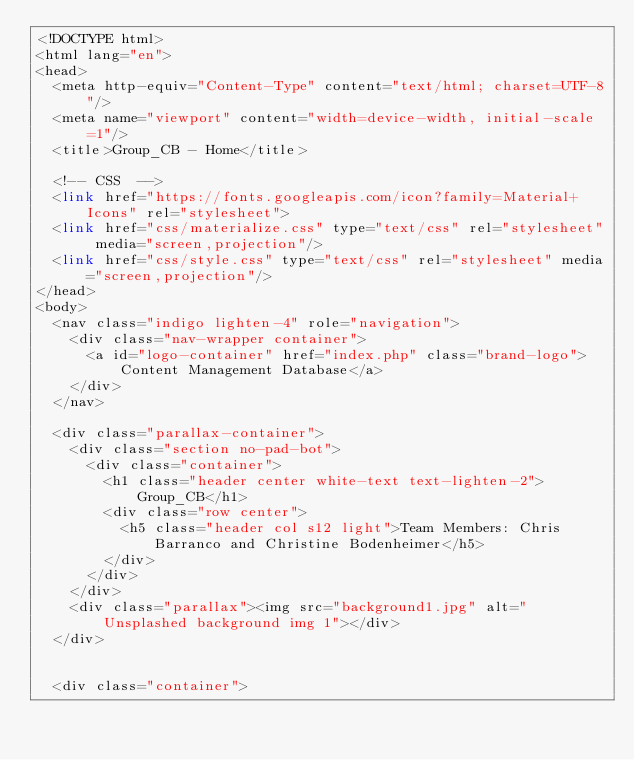Convert code to text. <code><loc_0><loc_0><loc_500><loc_500><_PHP_><!DOCTYPE html>
<html lang="en">
<head>
  <meta http-equiv="Content-Type" content="text/html; charset=UTF-8"/>
  <meta name="viewport" content="width=device-width, initial-scale=1"/>
  <title>Group_CB - Home</title>

  <!-- CSS  -->
  <link href="https://fonts.googleapis.com/icon?family=Material+Icons" rel="stylesheet">
  <link href="css/materialize.css" type="text/css" rel="stylesheet" media="screen,projection"/>
  <link href="css/style.css" type="text/css" rel="stylesheet" media="screen,projection"/>
</head>
<body>
  <nav class="indigo lighten-4" role="navigation">
    <div class="nav-wrapper container">
      <a id="logo-container" href="index.php" class="brand-logo">Content Management Database</a>
    </div>
  </nav>

  <div class="parallax-container">
    <div class="section no-pad-bot">
      <div class="container">
        <h1 class="header center white-text text-lighten-2">Group_CB</h1>
        <div class="row center">
          <h5 class="header col s12 light">Team Members: Chris Barranco and Christine Bodenheimer</h5>
        </div>
      </div>
    </div>
    <div class="parallax"><img src="background1.jpg" alt="Unsplashed background img 1"></div>
  </div>


  <div class="container"></code> 